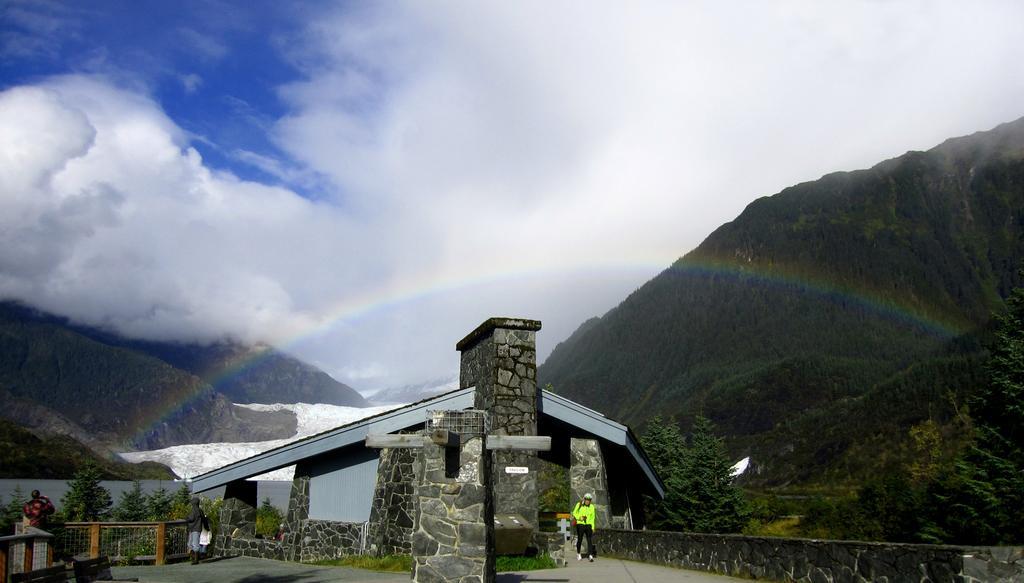Could you give a brief overview of what you see in this image? In the middle of the image there are stones pillars. Behind the pillars there are stone walls and also there is a roof. And on the floor there are two people standing. To the left side of the image there is a fencing and to the right side of the image there is a stone fencing. In the background there are few hills and trees. And also there is a rainbow. To the top of the image there is a sky with clouds. 